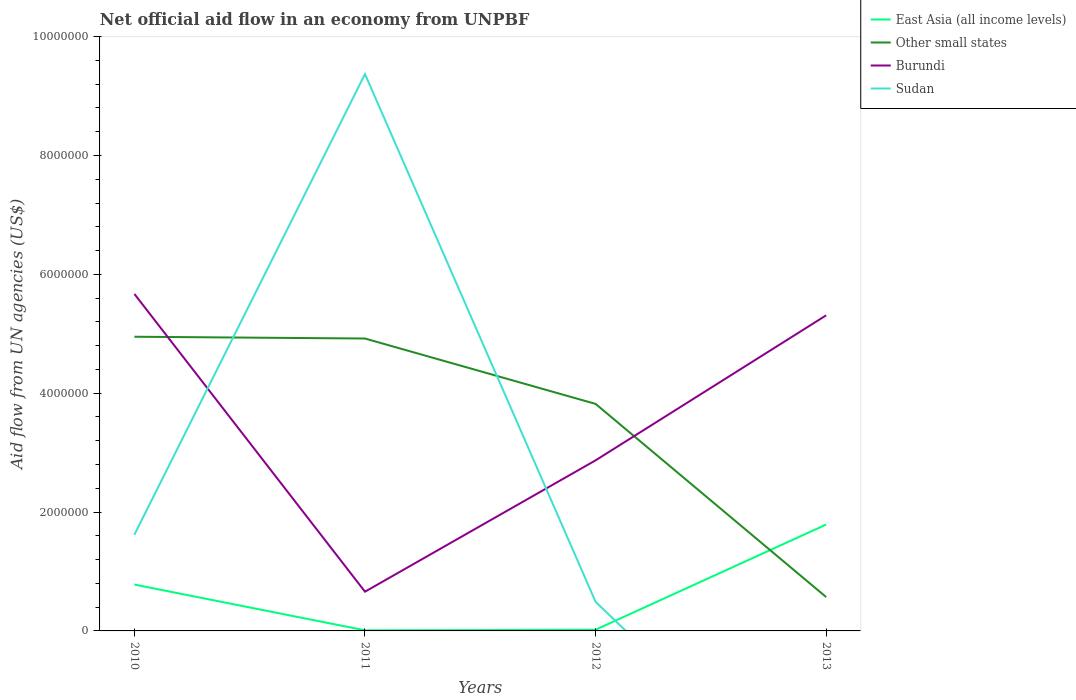Across all years, what is the maximum net official aid flow in East Asia (all income levels)?
Offer a very short reply. 10000. What is the total net official aid flow in Burundi in the graph?
Offer a very short reply. -4.65e+06. What is the difference between the highest and the second highest net official aid flow in Other small states?
Offer a very short reply. 4.38e+06. What is the difference between the highest and the lowest net official aid flow in Other small states?
Give a very brief answer. 3. Is the net official aid flow in Sudan strictly greater than the net official aid flow in Other small states over the years?
Your answer should be compact. No. How many years are there in the graph?
Give a very brief answer. 4. What is the difference between two consecutive major ticks on the Y-axis?
Provide a succinct answer. 2.00e+06. How many legend labels are there?
Provide a short and direct response. 4. How are the legend labels stacked?
Make the answer very short. Vertical. What is the title of the graph?
Provide a short and direct response. Net official aid flow in an economy from UNPBF. Does "Guyana" appear as one of the legend labels in the graph?
Make the answer very short. No. What is the label or title of the X-axis?
Give a very brief answer. Years. What is the label or title of the Y-axis?
Your answer should be compact. Aid flow from UN agencies (US$). What is the Aid flow from UN agencies (US$) in East Asia (all income levels) in 2010?
Your answer should be compact. 7.80e+05. What is the Aid flow from UN agencies (US$) of Other small states in 2010?
Provide a succinct answer. 4.95e+06. What is the Aid flow from UN agencies (US$) of Burundi in 2010?
Your answer should be very brief. 5.67e+06. What is the Aid flow from UN agencies (US$) of Sudan in 2010?
Provide a short and direct response. 1.62e+06. What is the Aid flow from UN agencies (US$) in East Asia (all income levels) in 2011?
Offer a terse response. 10000. What is the Aid flow from UN agencies (US$) in Other small states in 2011?
Ensure brevity in your answer.  4.92e+06. What is the Aid flow from UN agencies (US$) in Sudan in 2011?
Keep it short and to the point. 9.37e+06. What is the Aid flow from UN agencies (US$) in East Asia (all income levels) in 2012?
Ensure brevity in your answer.  2.00e+04. What is the Aid flow from UN agencies (US$) in Other small states in 2012?
Make the answer very short. 3.82e+06. What is the Aid flow from UN agencies (US$) in Burundi in 2012?
Give a very brief answer. 2.87e+06. What is the Aid flow from UN agencies (US$) of East Asia (all income levels) in 2013?
Offer a terse response. 1.79e+06. What is the Aid flow from UN agencies (US$) in Other small states in 2013?
Provide a short and direct response. 5.70e+05. What is the Aid flow from UN agencies (US$) in Burundi in 2013?
Your response must be concise. 5.31e+06. Across all years, what is the maximum Aid flow from UN agencies (US$) of East Asia (all income levels)?
Offer a terse response. 1.79e+06. Across all years, what is the maximum Aid flow from UN agencies (US$) of Other small states?
Offer a very short reply. 4.95e+06. Across all years, what is the maximum Aid flow from UN agencies (US$) of Burundi?
Provide a succinct answer. 5.67e+06. Across all years, what is the maximum Aid flow from UN agencies (US$) of Sudan?
Provide a succinct answer. 9.37e+06. Across all years, what is the minimum Aid flow from UN agencies (US$) in Other small states?
Ensure brevity in your answer.  5.70e+05. Across all years, what is the minimum Aid flow from UN agencies (US$) in Burundi?
Give a very brief answer. 6.60e+05. What is the total Aid flow from UN agencies (US$) in East Asia (all income levels) in the graph?
Your answer should be very brief. 2.60e+06. What is the total Aid flow from UN agencies (US$) of Other small states in the graph?
Your answer should be very brief. 1.43e+07. What is the total Aid flow from UN agencies (US$) of Burundi in the graph?
Provide a succinct answer. 1.45e+07. What is the total Aid flow from UN agencies (US$) in Sudan in the graph?
Keep it short and to the point. 1.15e+07. What is the difference between the Aid flow from UN agencies (US$) in East Asia (all income levels) in 2010 and that in 2011?
Your response must be concise. 7.70e+05. What is the difference between the Aid flow from UN agencies (US$) of Burundi in 2010 and that in 2011?
Your answer should be very brief. 5.01e+06. What is the difference between the Aid flow from UN agencies (US$) of Sudan in 2010 and that in 2011?
Your answer should be compact. -7.75e+06. What is the difference between the Aid flow from UN agencies (US$) in East Asia (all income levels) in 2010 and that in 2012?
Provide a short and direct response. 7.60e+05. What is the difference between the Aid flow from UN agencies (US$) of Other small states in 2010 and that in 2012?
Keep it short and to the point. 1.13e+06. What is the difference between the Aid flow from UN agencies (US$) in Burundi in 2010 and that in 2012?
Offer a terse response. 2.80e+06. What is the difference between the Aid flow from UN agencies (US$) of Sudan in 2010 and that in 2012?
Your answer should be compact. 1.13e+06. What is the difference between the Aid flow from UN agencies (US$) of East Asia (all income levels) in 2010 and that in 2013?
Give a very brief answer. -1.01e+06. What is the difference between the Aid flow from UN agencies (US$) of Other small states in 2010 and that in 2013?
Provide a succinct answer. 4.38e+06. What is the difference between the Aid flow from UN agencies (US$) of East Asia (all income levels) in 2011 and that in 2012?
Ensure brevity in your answer.  -10000. What is the difference between the Aid flow from UN agencies (US$) in Other small states in 2011 and that in 2012?
Provide a short and direct response. 1.10e+06. What is the difference between the Aid flow from UN agencies (US$) of Burundi in 2011 and that in 2012?
Offer a very short reply. -2.21e+06. What is the difference between the Aid flow from UN agencies (US$) in Sudan in 2011 and that in 2012?
Make the answer very short. 8.88e+06. What is the difference between the Aid flow from UN agencies (US$) in East Asia (all income levels) in 2011 and that in 2013?
Offer a very short reply. -1.78e+06. What is the difference between the Aid flow from UN agencies (US$) of Other small states in 2011 and that in 2013?
Your answer should be very brief. 4.35e+06. What is the difference between the Aid flow from UN agencies (US$) in Burundi in 2011 and that in 2013?
Offer a very short reply. -4.65e+06. What is the difference between the Aid flow from UN agencies (US$) of East Asia (all income levels) in 2012 and that in 2013?
Make the answer very short. -1.77e+06. What is the difference between the Aid flow from UN agencies (US$) in Other small states in 2012 and that in 2013?
Give a very brief answer. 3.25e+06. What is the difference between the Aid flow from UN agencies (US$) in Burundi in 2012 and that in 2013?
Offer a terse response. -2.44e+06. What is the difference between the Aid flow from UN agencies (US$) in East Asia (all income levels) in 2010 and the Aid flow from UN agencies (US$) in Other small states in 2011?
Offer a terse response. -4.14e+06. What is the difference between the Aid flow from UN agencies (US$) of East Asia (all income levels) in 2010 and the Aid flow from UN agencies (US$) of Sudan in 2011?
Make the answer very short. -8.59e+06. What is the difference between the Aid flow from UN agencies (US$) of Other small states in 2010 and the Aid flow from UN agencies (US$) of Burundi in 2011?
Provide a succinct answer. 4.29e+06. What is the difference between the Aid flow from UN agencies (US$) in Other small states in 2010 and the Aid flow from UN agencies (US$) in Sudan in 2011?
Your response must be concise. -4.42e+06. What is the difference between the Aid flow from UN agencies (US$) of Burundi in 2010 and the Aid flow from UN agencies (US$) of Sudan in 2011?
Offer a very short reply. -3.70e+06. What is the difference between the Aid flow from UN agencies (US$) in East Asia (all income levels) in 2010 and the Aid flow from UN agencies (US$) in Other small states in 2012?
Provide a succinct answer. -3.04e+06. What is the difference between the Aid flow from UN agencies (US$) of East Asia (all income levels) in 2010 and the Aid flow from UN agencies (US$) of Burundi in 2012?
Give a very brief answer. -2.09e+06. What is the difference between the Aid flow from UN agencies (US$) of Other small states in 2010 and the Aid flow from UN agencies (US$) of Burundi in 2012?
Provide a succinct answer. 2.08e+06. What is the difference between the Aid flow from UN agencies (US$) in Other small states in 2010 and the Aid flow from UN agencies (US$) in Sudan in 2012?
Keep it short and to the point. 4.46e+06. What is the difference between the Aid flow from UN agencies (US$) of Burundi in 2010 and the Aid flow from UN agencies (US$) of Sudan in 2012?
Provide a short and direct response. 5.18e+06. What is the difference between the Aid flow from UN agencies (US$) in East Asia (all income levels) in 2010 and the Aid flow from UN agencies (US$) in Burundi in 2013?
Keep it short and to the point. -4.53e+06. What is the difference between the Aid flow from UN agencies (US$) in Other small states in 2010 and the Aid flow from UN agencies (US$) in Burundi in 2013?
Make the answer very short. -3.60e+05. What is the difference between the Aid flow from UN agencies (US$) of East Asia (all income levels) in 2011 and the Aid flow from UN agencies (US$) of Other small states in 2012?
Provide a succinct answer. -3.81e+06. What is the difference between the Aid flow from UN agencies (US$) in East Asia (all income levels) in 2011 and the Aid flow from UN agencies (US$) in Burundi in 2012?
Offer a very short reply. -2.86e+06. What is the difference between the Aid flow from UN agencies (US$) of East Asia (all income levels) in 2011 and the Aid flow from UN agencies (US$) of Sudan in 2012?
Provide a short and direct response. -4.80e+05. What is the difference between the Aid flow from UN agencies (US$) in Other small states in 2011 and the Aid flow from UN agencies (US$) in Burundi in 2012?
Provide a succinct answer. 2.05e+06. What is the difference between the Aid flow from UN agencies (US$) in Other small states in 2011 and the Aid flow from UN agencies (US$) in Sudan in 2012?
Your answer should be very brief. 4.43e+06. What is the difference between the Aid flow from UN agencies (US$) of East Asia (all income levels) in 2011 and the Aid flow from UN agencies (US$) of Other small states in 2013?
Your answer should be very brief. -5.60e+05. What is the difference between the Aid flow from UN agencies (US$) in East Asia (all income levels) in 2011 and the Aid flow from UN agencies (US$) in Burundi in 2013?
Give a very brief answer. -5.30e+06. What is the difference between the Aid flow from UN agencies (US$) of Other small states in 2011 and the Aid flow from UN agencies (US$) of Burundi in 2013?
Your response must be concise. -3.90e+05. What is the difference between the Aid flow from UN agencies (US$) of East Asia (all income levels) in 2012 and the Aid flow from UN agencies (US$) of Other small states in 2013?
Your response must be concise. -5.50e+05. What is the difference between the Aid flow from UN agencies (US$) of East Asia (all income levels) in 2012 and the Aid flow from UN agencies (US$) of Burundi in 2013?
Provide a short and direct response. -5.29e+06. What is the difference between the Aid flow from UN agencies (US$) in Other small states in 2012 and the Aid flow from UN agencies (US$) in Burundi in 2013?
Offer a terse response. -1.49e+06. What is the average Aid flow from UN agencies (US$) in East Asia (all income levels) per year?
Offer a terse response. 6.50e+05. What is the average Aid flow from UN agencies (US$) of Other small states per year?
Provide a short and direct response. 3.56e+06. What is the average Aid flow from UN agencies (US$) of Burundi per year?
Give a very brief answer. 3.63e+06. What is the average Aid flow from UN agencies (US$) in Sudan per year?
Keep it short and to the point. 2.87e+06. In the year 2010, what is the difference between the Aid flow from UN agencies (US$) in East Asia (all income levels) and Aid flow from UN agencies (US$) in Other small states?
Offer a terse response. -4.17e+06. In the year 2010, what is the difference between the Aid flow from UN agencies (US$) in East Asia (all income levels) and Aid flow from UN agencies (US$) in Burundi?
Your response must be concise. -4.89e+06. In the year 2010, what is the difference between the Aid flow from UN agencies (US$) of East Asia (all income levels) and Aid flow from UN agencies (US$) of Sudan?
Your response must be concise. -8.40e+05. In the year 2010, what is the difference between the Aid flow from UN agencies (US$) of Other small states and Aid flow from UN agencies (US$) of Burundi?
Provide a short and direct response. -7.20e+05. In the year 2010, what is the difference between the Aid flow from UN agencies (US$) in Other small states and Aid flow from UN agencies (US$) in Sudan?
Keep it short and to the point. 3.33e+06. In the year 2010, what is the difference between the Aid flow from UN agencies (US$) of Burundi and Aid flow from UN agencies (US$) of Sudan?
Give a very brief answer. 4.05e+06. In the year 2011, what is the difference between the Aid flow from UN agencies (US$) in East Asia (all income levels) and Aid flow from UN agencies (US$) in Other small states?
Ensure brevity in your answer.  -4.91e+06. In the year 2011, what is the difference between the Aid flow from UN agencies (US$) in East Asia (all income levels) and Aid flow from UN agencies (US$) in Burundi?
Keep it short and to the point. -6.50e+05. In the year 2011, what is the difference between the Aid flow from UN agencies (US$) in East Asia (all income levels) and Aid flow from UN agencies (US$) in Sudan?
Your answer should be compact. -9.36e+06. In the year 2011, what is the difference between the Aid flow from UN agencies (US$) in Other small states and Aid flow from UN agencies (US$) in Burundi?
Give a very brief answer. 4.26e+06. In the year 2011, what is the difference between the Aid flow from UN agencies (US$) in Other small states and Aid flow from UN agencies (US$) in Sudan?
Keep it short and to the point. -4.45e+06. In the year 2011, what is the difference between the Aid flow from UN agencies (US$) in Burundi and Aid flow from UN agencies (US$) in Sudan?
Offer a terse response. -8.71e+06. In the year 2012, what is the difference between the Aid flow from UN agencies (US$) in East Asia (all income levels) and Aid flow from UN agencies (US$) in Other small states?
Your answer should be compact. -3.80e+06. In the year 2012, what is the difference between the Aid flow from UN agencies (US$) in East Asia (all income levels) and Aid flow from UN agencies (US$) in Burundi?
Provide a short and direct response. -2.85e+06. In the year 2012, what is the difference between the Aid flow from UN agencies (US$) of East Asia (all income levels) and Aid flow from UN agencies (US$) of Sudan?
Keep it short and to the point. -4.70e+05. In the year 2012, what is the difference between the Aid flow from UN agencies (US$) in Other small states and Aid flow from UN agencies (US$) in Burundi?
Offer a very short reply. 9.50e+05. In the year 2012, what is the difference between the Aid flow from UN agencies (US$) of Other small states and Aid flow from UN agencies (US$) of Sudan?
Offer a very short reply. 3.33e+06. In the year 2012, what is the difference between the Aid flow from UN agencies (US$) of Burundi and Aid flow from UN agencies (US$) of Sudan?
Your response must be concise. 2.38e+06. In the year 2013, what is the difference between the Aid flow from UN agencies (US$) of East Asia (all income levels) and Aid flow from UN agencies (US$) of Other small states?
Your answer should be very brief. 1.22e+06. In the year 2013, what is the difference between the Aid flow from UN agencies (US$) in East Asia (all income levels) and Aid flow from UN agencies (US$) in Burundi?
Your answer should be compact. -3.52e+06. In the year 2013, what is the difference between the Aid flow from UN agencies (US$) in Other small states and Aid flow from UN agencies (US$) in Burundi?
Provide a short and direct response. -4.74e+06. What is the ratio of the Aid flow from UN agencies (US$) of East Asia (all income levels) in 2010 to that in 2011?
Keep it short and to the point. 78. What is the ratio of the Aid flow from UN agencies (US$) of Burundi in 2010 to that in 2011?
Your answer should be compact. 8.59. What is the ratio of the Aid flow from UN agencies (US$) of Sudan in 2010 to that in 2011?
Make the answer very short. 0.17. What is the ratio of the Aid flow from UN agencies (US$) in Other small states in 2010 to that in 2012?
Provide a succinct answer. 1.3. What is the ratio of the Aid flow from UN agencies (US$) of Burundi in 2010 to that in 2012?
Ensure brevity in your answer.  1.98. What is the ratio of the Aid flow from UN agencies (US$) in Sudan in 2010 to that in 2012?
Provide a short and direct response. 3.31. What is the ratio of the Aid flow from UN agencies (US$) in East Asia (all income levels) in 2010 to that in 2013?
Provide a short and direct response. 0.44. What is the ratio of the Aid flow from UN agencies (US$) in Other small states in 2010 to that in 2013?
Provide a short and direct response. 8.68. What is the ratio of the Aid flow from UN agencies (US$) in Burundi in 2010 to that in 2013?
Your response must be concise. 1.07. What is the ratio of the Aid flow from UN agencies (US$) of Other small states in 2011 to that in 2012?
Offer a very short reply. 1.29. What is the ratio of the Aid flow from UN agencies (US$) of Burundi in 2011 to that in 2012?
Your answer should be very brief. 0.23. What is the ratio of the Aid flow from UN agencies (US$) in Sudan in 2011 to that in 2012?
Your answer should be very brief. 19.12. What is the ratio of the Aid flow from UN agencies (US$) in East Asia (all income levels) in 2011 to that in 2013?
Your response must be concise. 0.01. What is the ratio of the Aid flow from UN agencies (US$) in Other small states in 2011 to that in 2013?
Keep it short and to the point. 8.63. What is the ratio of the Aid flow from UN agencies (US$) of Burundi in 2011 to that in 2013?
Your response must be concise. 0.12. What is the ratio of the Aid flow from UN agencies (US$) of East Asia (all income levels) in 2012 to that in 2013?
Provide a short and direct response. 0.01. What is the ratio of the Aid flow from UN agencies (US$) in Other small states in 2012 to that in 2013?
Provide a short and direct response. 6.7. What is the ratio of the Aid flow from UN agencies (US$) in Burundi in 2012 to that in 2013?
Ensure brevity in your answer.  0.54. What is the difference between the highest and the second highest Aid flow from UN agencies (US$) of East Asia (all income levels)?
Offer a very short reply. 1.01e+06. What is the difference between the highest and the second highest Aid flow from UN agencies (US$) in Burundi?
Make the answer very short. 3.60e+05. What is the difference between the highest and the second highest Aid flow from UN agencies (US$) in Sudan?
Offer a terse response. 7.75e+06. What is the difference between the highest and the lowest Aid flow from UN agencies (US$) in East Asia (all income levels)?
Provide a short and direct response. 1.78e+06. What is the difference between the highest and the lowest Aid flow from UN agencies (US$) in Other small states?
Your answer should be compact. 4.38e+06. What is the difference between the highest and the lowest Aid flow from UN agencies (US$) of Burundi?
Offer a very short reply. 5.01e+06. What is the difference between the highest and the lowest Aid flow from UN agencies (US$) of Sudan?
Ensure brevity in your answer.  9.37e+06. 